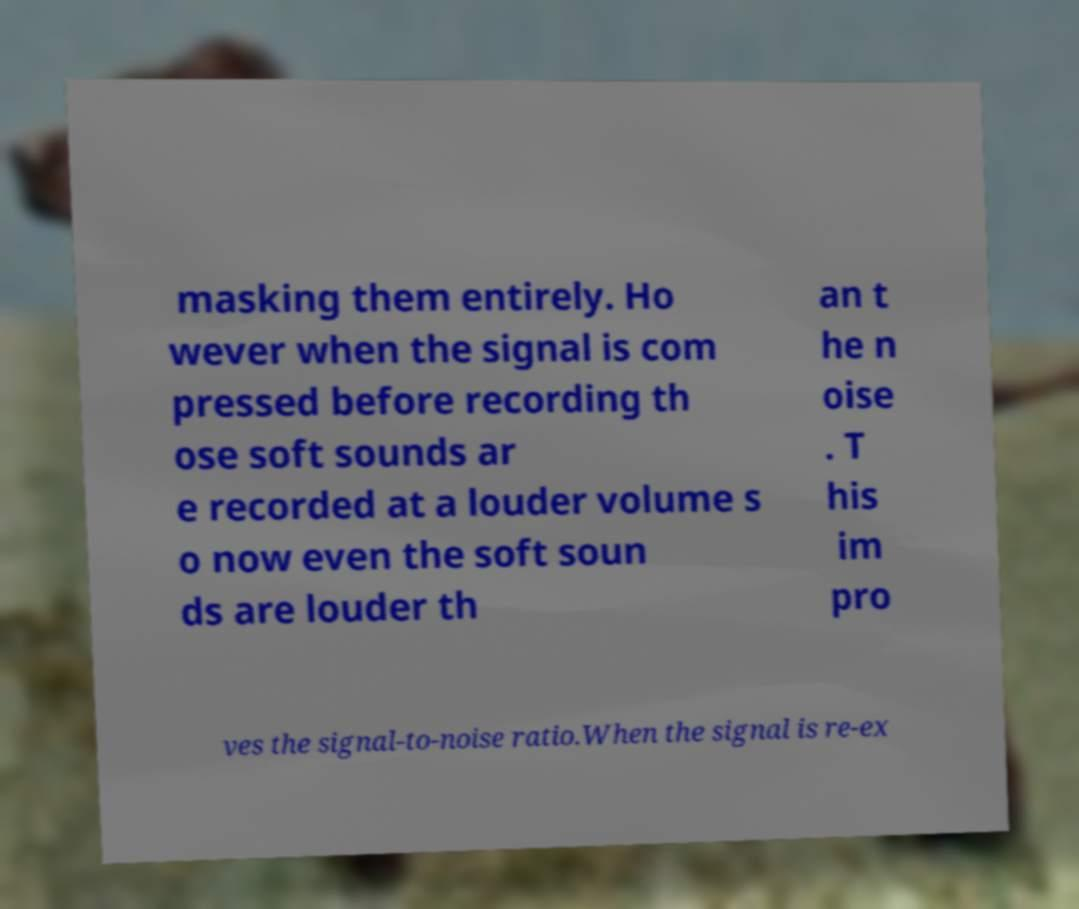There's text embedded in this image that I need extracted. Can you transcribe it verbatim? masking them entirely. Ho wever when the signal is com pressed before recording th ose soft sounds ar e recorded at a louder volume s o now even the soft soun ds are louder th an t he n oise . T his im pro ves the signal-to-noise ratio.When the signal is re-ex 